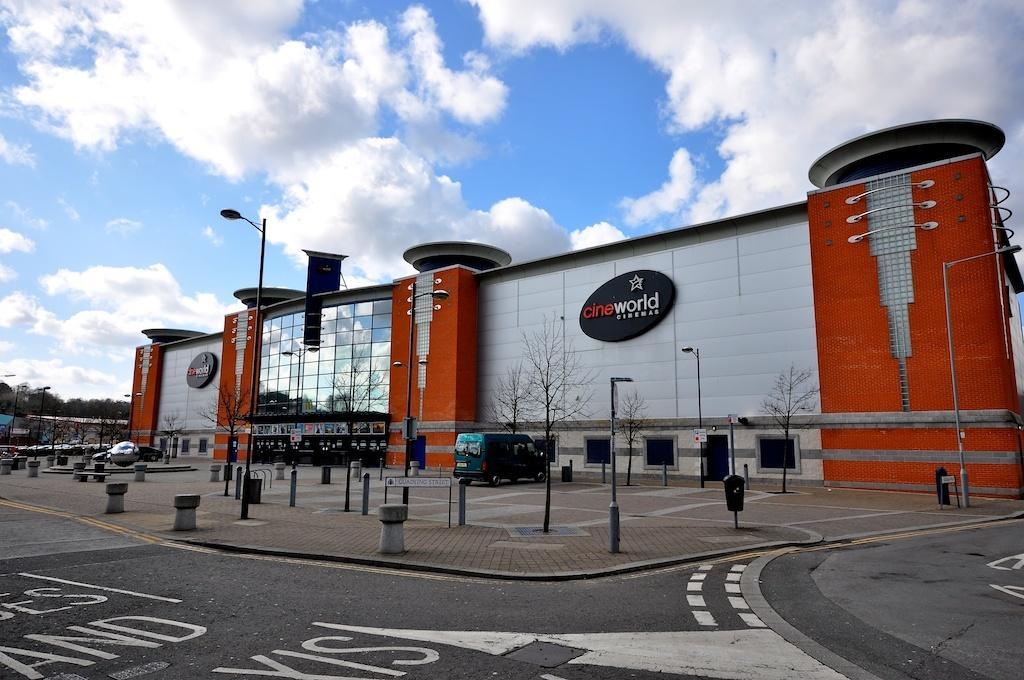In one or two sentences, can you explain what this image depicts? In this image there are poles in the center and there is a car on the road which is green in colour and there is a building, on the wall of the building there is a board and there is some text written on board. On the left side there are trees and there is a car moving on the road and the sky is cloudy. 